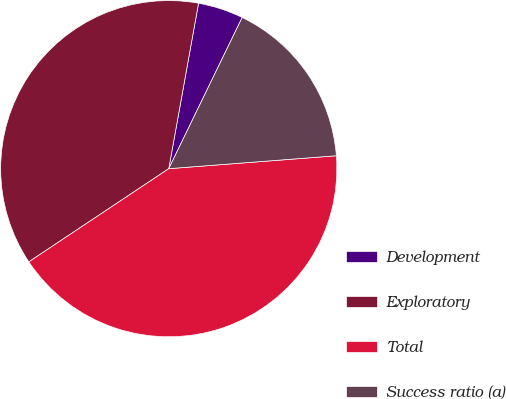Convert chart to OTSL. <chart><loc_0><loc_0><loc_500><loc_500><pie_chart><fcel>Development<fcel>Exploratory<fcel>Total<fcel>Success ratio (a)<nl><fcel>4.36%<fcel>37.19%<fcel>41.88%<fcel>16.58%<nl></chart> 